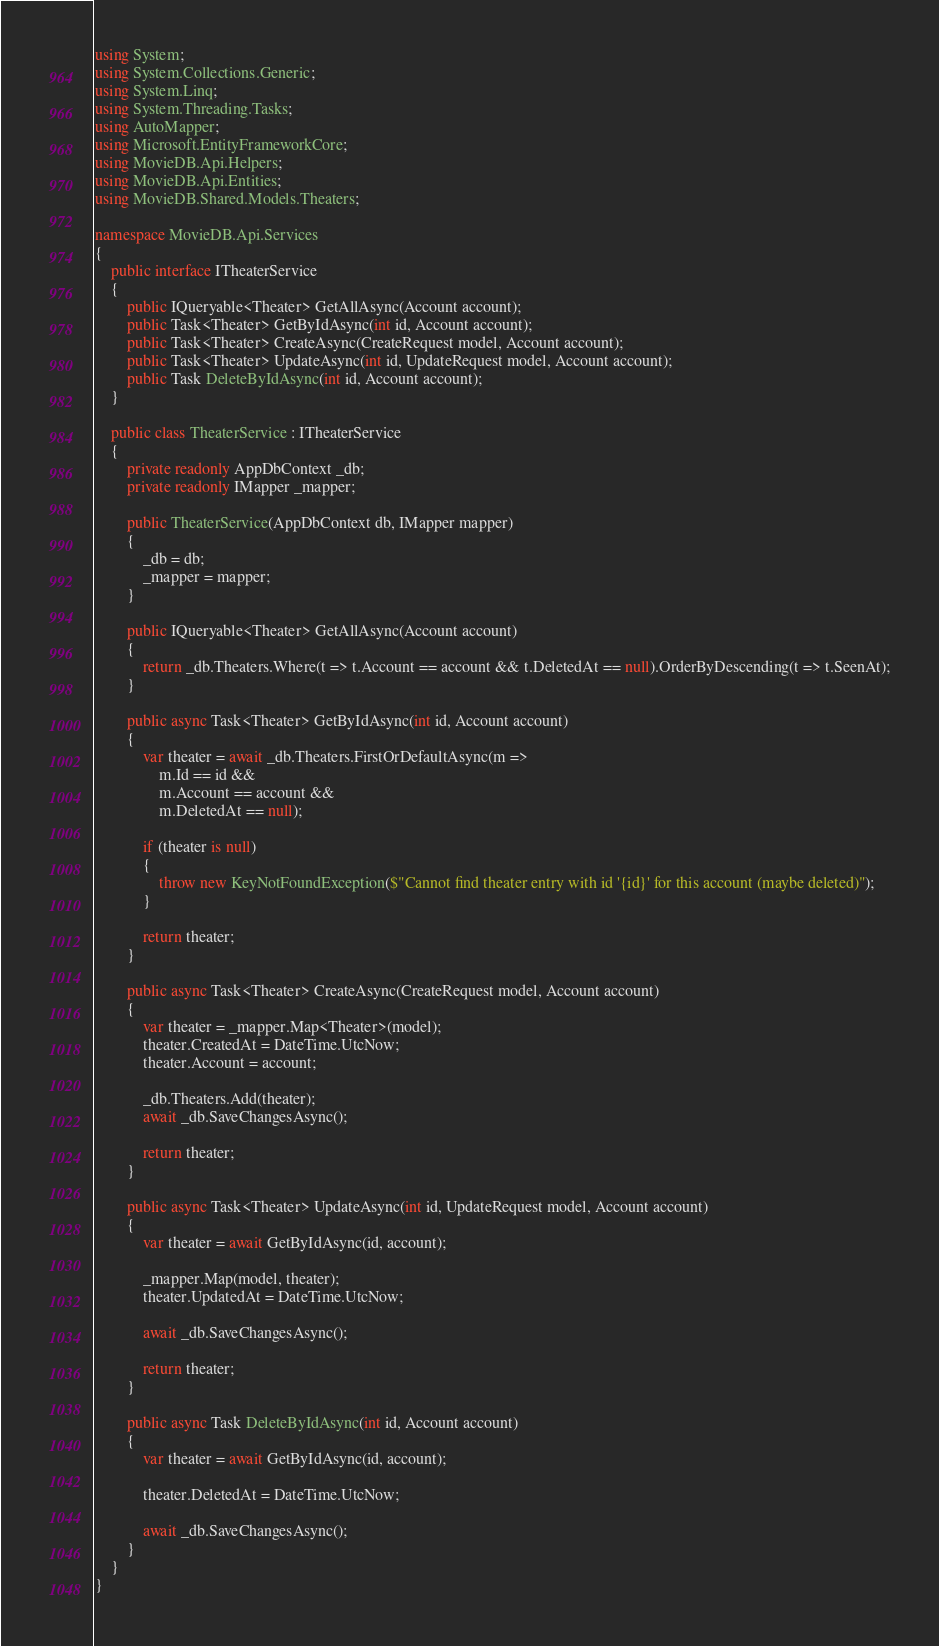Convert code to text. <code><loc_0><loc_0><loc_500><loc_500><_C#_>using System;
using System.Collections.Generic;
using System.Linq;
using System.Threading.Tasks;
using AutoMapper;
using Microsoft.EntityFrameworkCore;
using MovieDB.Api.Helpers;
using MovieDB.Api.Entities;
using MovieDB.Shared.Models.Theaters;

namespace MovieDB.Api.Services
{
    public interface ITheaterService
    {
        public IQueryable<Theater> GetAllAsync(Account account);
        public Task<Theater> GetByIdAsync(int id, Account account);
        public Task<Theater> CreateAsync(CreateRequest model, Account account);
        public Task<Theater> UpdateAsync(int id, UpdateRequest model, Account account);
        public Task DeleteByIdAsync(int id, Account account);
    }

    public class TheaterService : ITheaterService
    {
        private readonly AppDbContext _db;
        private readonly IMapper _mapper;

        public TheaterService(AppDbContext db, IMapper mapper)
        {
            _db = db;
            _mapper = mapper;
        }

        public IQueryable<Theater> GetAllAsync(Account account)
        {
            return _db.Theaters.Where(t => t.Account == account && t.DeletedAt == null).OrderByDescending(t => t.SeenAt);
        }

        public async Task<Theater> GetByIdAsync(int id, Account account)
        {
            var theater = await _db.Theaters.FirstOrDefaultAsync(m =>
                m.Id == id &&
                m.Account == account &&
                m.DeletedAt == null);

            if (theater is null)
            {
                throw new KeyNotFoundException($"Cannot find theater entry with id '{id}' for this account (maybe deleted)");
            }

            return theater;
        }

        public async Task<Theater> CreateAsync(CreateRequest model, Account account)
        {
            var theater = _mapper.Map<Theater>(model);
            theater.CreatedAt = DateTime.UtcNow;
            theater.Account = account;

            _db.Theaters.Add(theater);
            await _db.SaveChangesAsync();

            return theater;
        }

        public async Task<Theater> UpdateAsync(int id, UpdateRequest model, Account account)
        {
            var theater = await GetByIdAsync(id, account);

            _mapper.Map(model, theater);
            theater.UpdatedAt = DateTime.UtcNow;

            await _db.SaveChangesAsync();

            return theater;
        }

        public async Task DeleteByIdAsync(int id, Account account)
        {
            var theater = await GetByIdAsync(id, account);

            theater.DeletedAt = DateTime.UtcNow;

            await _db.SaveChangesAsync();
        }
    }
}
</code> 